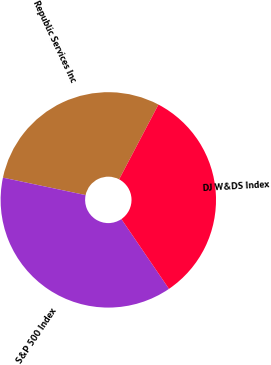Convert chart. <chart><loc_0><loc_0><loc_500><loc_500><pie_chart><fcel>Republic Services Inc<fcel>S&P 500 Index<fcel>DJ W&DS Index<nl><fcel>29.4%<fcel>37.84%<fcel>32.77%<nl></chart> 